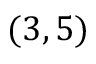Convert formula to latex. <formula><loc_0><loc_0><loc_500><loc_500>( 3 , 5 )</formula> 